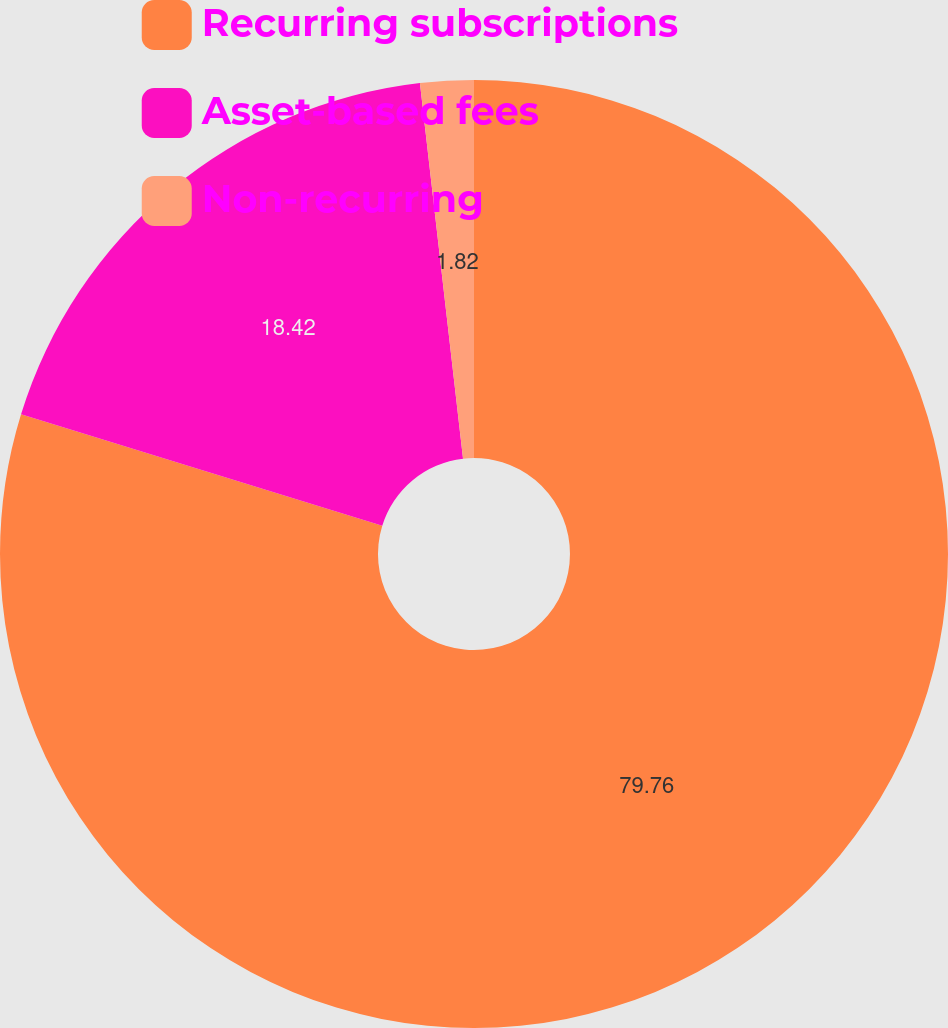Convert chart to OTSL. <chart><loc_0><loc_0><loc_500><loc_500><pie_chart><fcel>Recurring subscriptions<fcel>Asset-based fees<fcel>Non-recurring<nl><fcel>79.77%<fcel>18.42%<fcel>1.82%<nl></chart> 